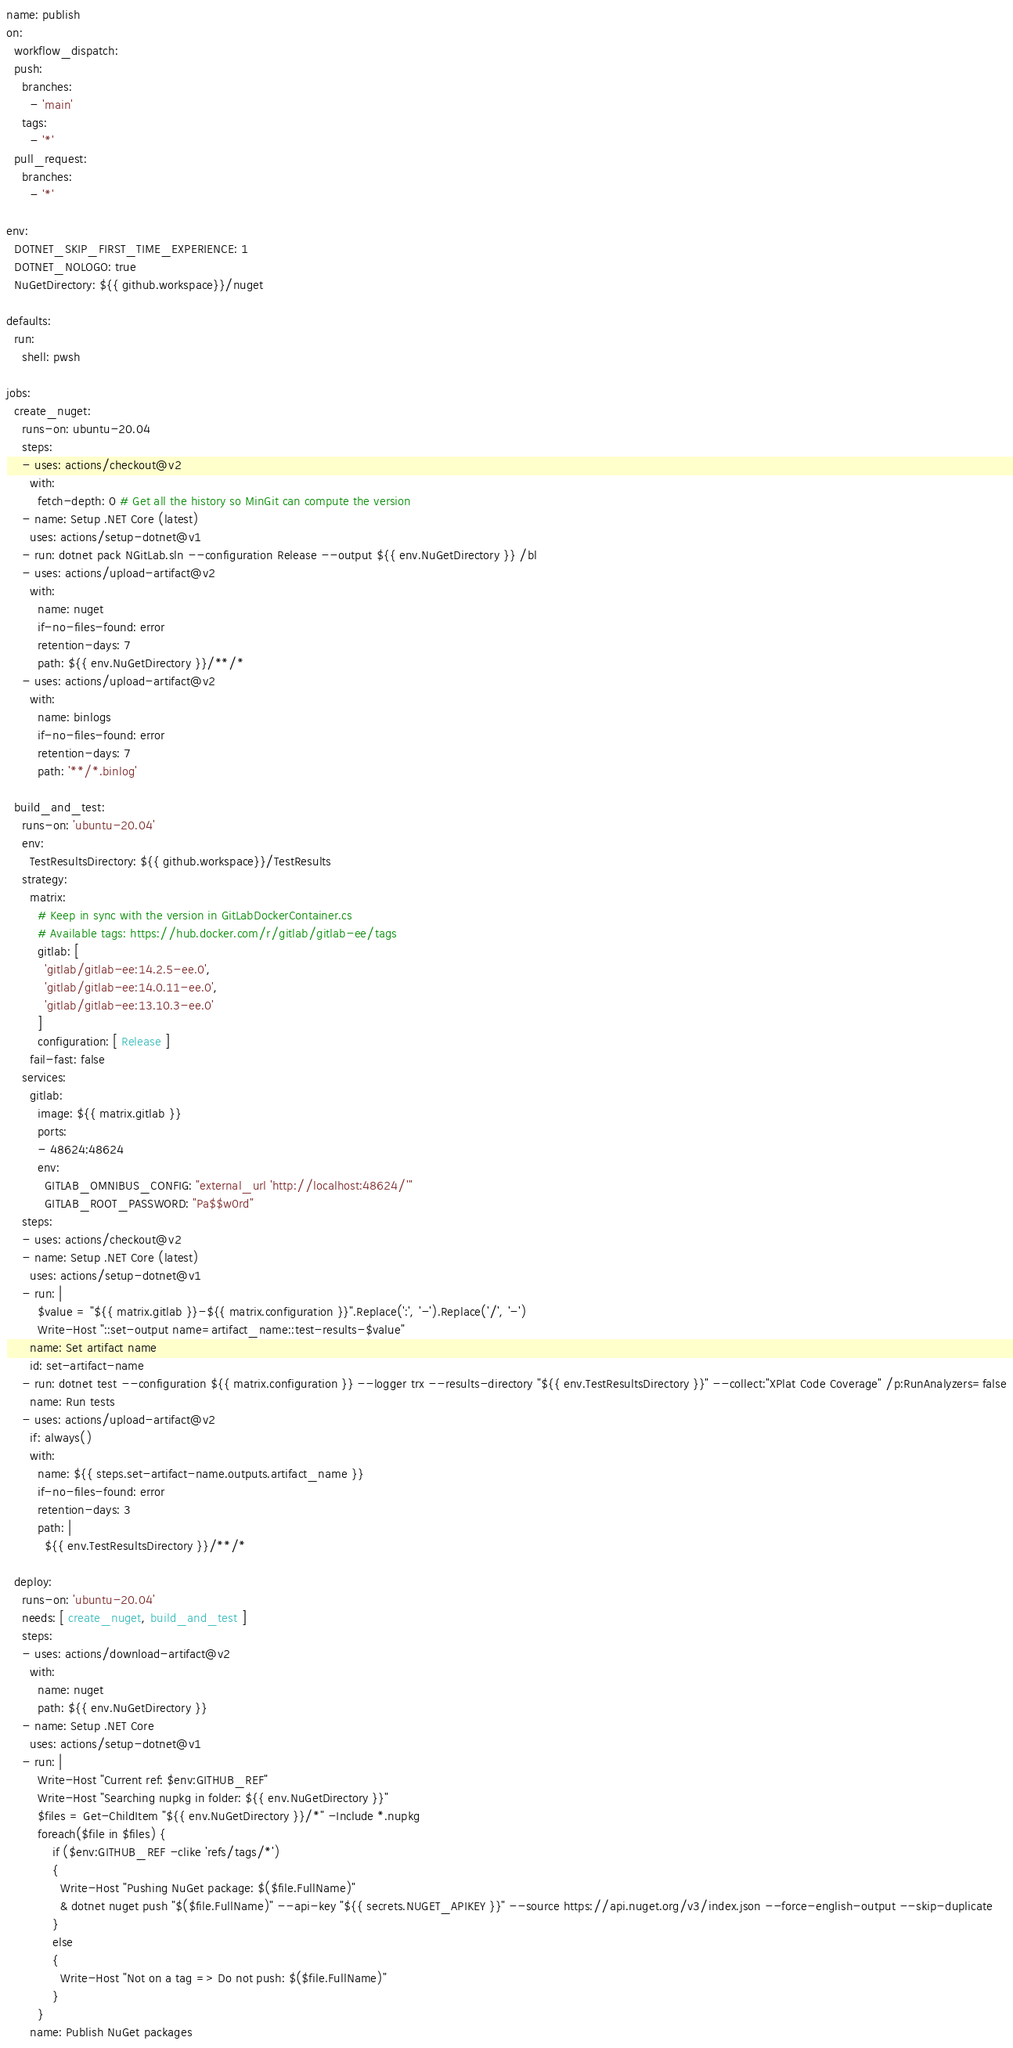Convert code to text. <code><loc_0><loc_0><loc_500><loc_500><_YAML_>name: publish
on:
  workflow_dispatch:
  push:
    branches:
      - 'main'
    tags:
      - '*'
  pull_request:
    branches:
      - '*'

env:
  DOTNET_SKIP_FIRST_TIME_EXPERIENCE: 1
  DOTNET_NOLOGO: true
  NuGetDirectory: ${{ github.workspace}}/nuget

defaults:
  run:
    shell: pwsh

jobs:
  create_nuget:
    runs-on: ubuntu-20.04
    steps:
    - uses: actions/checkout@v2
      with:
        fetch-depth: 0 # Get all the history so MinGit can compute the version
    - name: Setup .NET Core (latest)
      uses: actions/setup-dotnet@v1
    - run: dotnet pack NGitLab.sln --configuration Release --output ${{ env.NuGetDirectory }} /bl
    - uses: actions/upload-artifact@v2
      with:
        name: nuget
        if-no-files-found: error
        retention-days: 7
        path: ${{ env.NuGetDirectory }}/**/*
    - uses: actions/upload-artifact@v2
      with:
        name: binlogs
        if-no-files-found: error
        retention-days: 7
        path: '**/*.binlog'

  build_and_test:
    runs-on: 'ubuntu-20.04'
    env:
      TestResultsDirectory: ${{ github.workspace}}/TestResults
    strategy:
      matrix:
        # Keep in sync with the version in GitLabDockerContainer.cs
        # Available tags: https://hub.docker.com/r/gitlab/gitlab-ee/tags
        gitlab: [
          'gitlab/gitlab-ee:14.2.5-ee.0',
          'gitlab/gitlab-ee:14.0.11-ee.0',
          'gitlab/gitlab-ee:13.10.3-ee.0'
        ]
        configuration: [ Release ]
      fail-fast: false
    services:
      gitlab:
        image: ${{ matrix.gitlab }}
        ports:
        - 48624:48624
        env:
          GITLAB_OMNIBUS_CONFIG: "external_url 'http://localhost:48624/'"
          GITLAB_ROOT_PASSWORD: "Pa$$w0rd"
    steps:
    - uses: actions/checkout@v2
    - name: Setup .NET Core (latest)
      uses: actions/setup-dotnet@v1
    - run: |
        $value = "${{ matrix.gitlab }}-${{ matrix.configuration }}".Replace(':', '-').Replace('/', '-')
        Write-Host "::set-output name=artifact_name::test-results-$value"
      name: Set artifact name
      id: set-artifact-name
    - run: dotnet test --configuration ${{ matrix.configuration }} --logger trx --results-directory "${{ env.TestResultsDirectory }}" --collect:"XPlat Code Coverage" /p:RunAnalyzers=false
      name: Run tests
    - uses: actions/upload-artifact@v2
      if: always()
      with:
        name: ${{ steps.set-artifact-name.outputs.artifact_name }}
        if-no-files-found: error
        retention-days: 3
        path: |
          ${{ env.TestResultsDirectory }}/**/*

  deploy:
    runs-on: 'ubuntu-20.04'
    needs: [ create_nuget, build_and_test ]
    steps:
    - uses: actions/download-artifact@v2
      with:
        name: nuget
        path: ${{ env.NuGetDirectory }}
    - name: Setup .NET Core
      uses: actions/setup-dotnet@v1
    - run: |
        Write-Host "Current ref: $env:GITHUB_REF"
        Write-Host "Searching nupkg in folder: ${{ env.NuGetDirectory }}"
        $files = Get-ChildItem "${{ env.NuGetDirectory }}/*" -Include *.nupkg
        foreach($file in $files) {
            if ($env:GITHUB_REF -clike 'refs/tags/*')
            {
              Write-Host "Pushing NuGet package: $($file.FullName)"
              & dotnet nuget push "$($file.FullName)" --api-key "${{ secrets.NUGET_APIKEY }}" --source https://api.nuget.org/v3/index.json --force-english-output --skip-duplicate
            }
            else
            {
              Write-Host "Not on a tag => Do not push: $($file.FullName)"
            }
        }
      name: Publish NuGet packages
</code> 